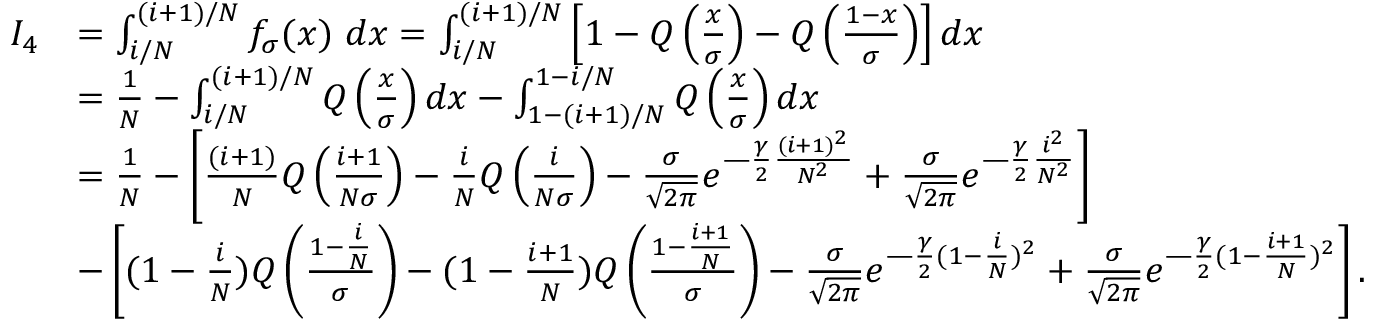<formula> <loc_0><loc_0><loc_500><loc_500>\begin{array} { r l } { I _ { 4 } } & { = \int _ { i / N } ^ { ( i + 1 ) / N } f _ { \sigma } ( x ) d x = \int _ { i / N } ^ { ( i + 1 ) / N } \left [ 1 - Q \left ( \frac { x } { \sigma } \right ) - Q \left ( \frac { 1 - x } { \sigma } \right ) \right ] d x } \\ & { = \frac { 1 } { N } - \int _ { i / N } ^ { ( i + 1 ) / N } Q \left ( \frac { x } { \sigma } \right ) d x - \int _ { 1 - ( i + 1 ) / N } ^ { 1 - i / N } Q \left ( \frac { x } { \sigma } \right ) d x } \\ & { = \frac { 1 } { N } - \left [ \frac { ( i + 1 ) } { N } Q \left ( \frac { i + 1 } { N \sigma } \right ) - \frac { i } { N } Q \left ( \frac { i } { N \sigma } \right ) - \frac { \sigma } { \sqrt { 2 \pi } } e ^ { \frac { \gamma } { 2 } \frac { ( i + 1 ) ^ { 2 } } { N ^ { 2 } } } + \frac { \sigma } { \sqrt { 2 \pi } } e ^ { \frac { \gamma } { 2 } \frac { i ^ { 2 } } { N ^ { 2 } } } \right ] } \\ & { - \left [ ( 1 - \frac { i } { N } ) Q \left ( \frac { 1 - \frac { i } { N } } { \sigma } \right ) - ( 1 - \frac { i + 1 } { N } ) Q \left ( \frac { 1 - \frac { i + 1 } { N } } { \sigma } \right ) - \frac { \sigma } { \sqrt { 2 \pi } } e ^ { \frac { \gamma } { 2 } ( 1 - \frac { i } { N } ) ^ { 2 } } + \frac { \sigma } { \sqrt { 2 \pi } } e ^ { \frac { \gamma } { 2 } ( 1 - \frac { i + 1 } { N } ) ^ { 2 } } \right ] . } \end{array}</formula> 